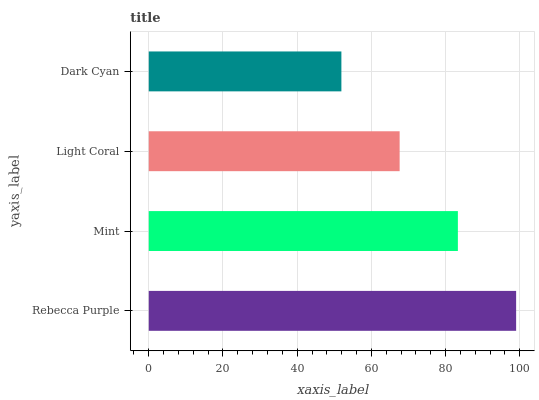Is Dark Cyan the minimum?
Answer yes or no. Yes. Is Rebecca Purple the maximum?
Answer yes or no. Yes. Is Mint the minimum?
Answer yes or no. No. Is Mint the maximum?
Answer yes or no. No. Is Rebecca Purple greater than Mint?
Answer yes or no. Yes. Is Mint less than Rebecca Purple?
Answer yes or no. Yes. Is Mint greater than Rebecca Purple?
Answer yes or no. No. Is Rebecca Purple less than Mint?
Answer yes or no. No. Is Mint the high median?
Answer yes or no. Yes. Is Light Coral the low median?
Answer yes or no. Yes. Is Light Coral the high median?
Answer yes or no. No. Is Dark Cyan the low median?
Answer yes or no. No. 